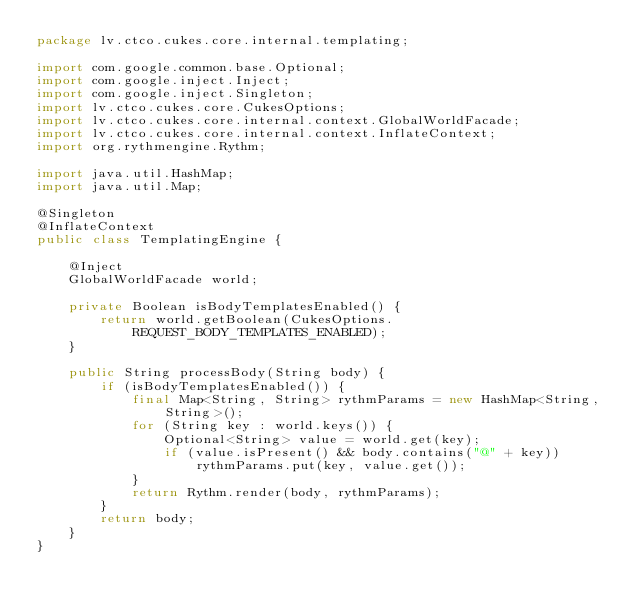Convert code to text. <code><loc_0><loc_0><loc_500><loc_500><_Java_>package lv.ctco.cukes.core.internal.templating;

import com.google.common.base.Optional;
import com.google.inject.Inject;
import com.google.inject.Singleton;
import lv.ctco.cukes.core.CukesOptions;
import lv.ctco.cukes.core.internal.context.GlobalWorldFacade;
import lv.ctco.cukes.core.internal.context.InflateContext;
import org.rythmengine.Rythm;

import java.util.HashMap;
import java.util.Map;

@Singleton
@InflateContext
public class TemplatingEngine {

    @Inject
    GlobalWorldFacade world;

    private Boolean isBodyTemplatesEnabled() {
        return world.getBoolean(CukesOptions.REQUEST_BODY_TEMPLATES_ENABLED);
    }

    public String processBody(String body) {
        if (isBodyTemplatesEnabled()) {
            final Map<String, String> rythmParams = new HashMap<String, String>();
            for (String key : world.keys()) {
                Optional<String> value = world.get(key);
                if (value.isPresent() && body.contains("@" + key)) rythmParams.put(key, value.get());
            }
            return Rythm.render(body, rythmParams);
        }
        return body;
    }
}
</code> 